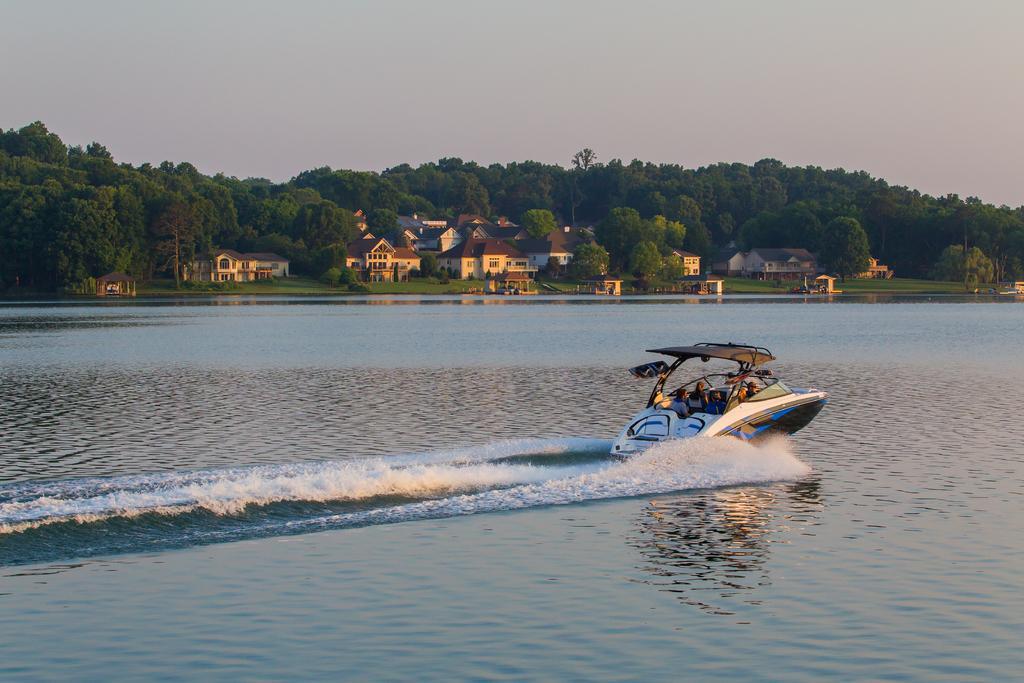Describe this image in one or two sentences. In this picture we can see a few people on a boat. Waves are visible in water. There are some trees and houses in the background. 